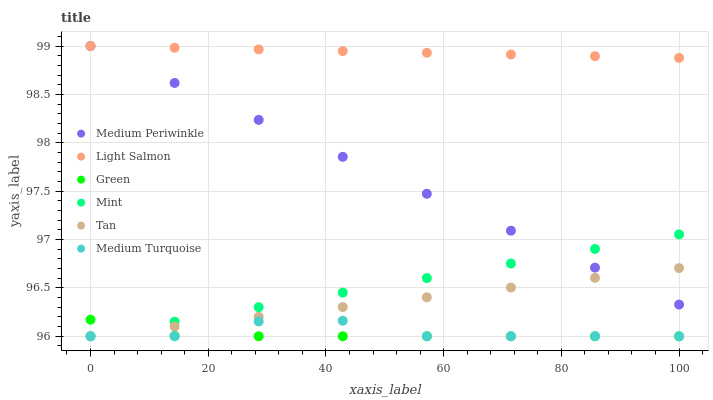Does Green have the minimum area under the curve?
Answer yes or no. Yes. Does Light Salmon have the maximum area under the curve?
Answer yes or no. Yes. Does Medium Periwinkle have the minimum area under the curve?
Answer yes or no. No. Does Medium Periwinkle have the maximum area under the curve?
Answer yes or no. No. Is Mint the smoothest?
Answer yes or no. Yes. Is Medium Turquoise the roughest?
Answer yes or no. Yes. Is Medium Periwinkle the smoothest?
Answer yes or no. No. Is Medium Periwinkle the roughest?
Answer yes or no. No. Does Green have the lowest value?
Answer yes or no. Yes. Does Medium Periwinkle have the lowest value?
Answer yes or no. No. Does Medium Periwinkle have the highest value?
Answer yes or no. Yes. Does Green have the highest value?
Answer yes or no. No. Is Green less than Light Salmon?
Answer yes or no. Yes. Is Light Salmon greater than Green?
Answer yes or no. Yes. Does Light Salmon intersect Medium Periwinkle?
Answer yes or no. Yes. Is Light Salmon less than Medium Periwinkle?
Answer yes or no. No. Is Light Salmon greater than Medium Periwinkle?
Answer yes or no. No. Does Green intersect Light Salmon?
Answer yes or no. No. 